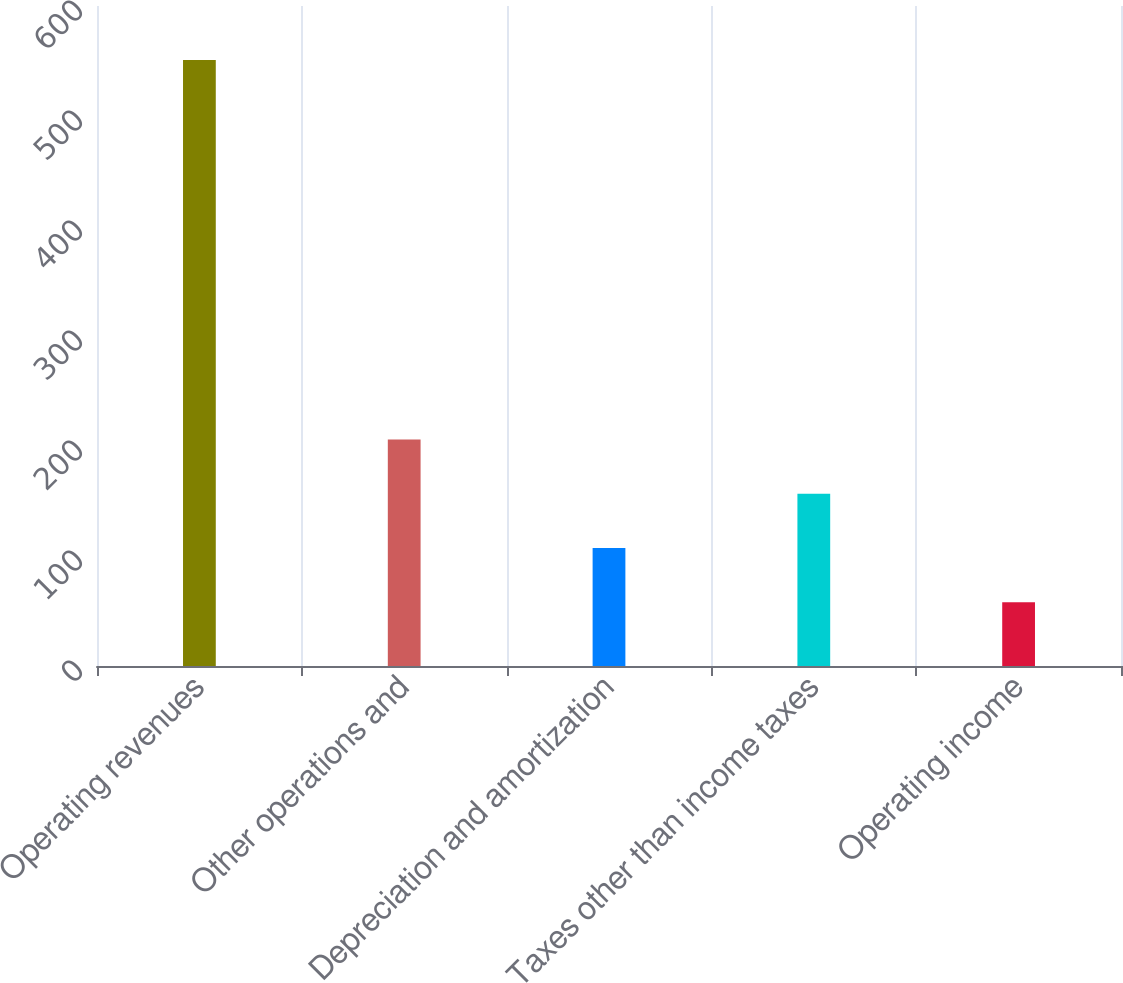<chart> <loc_0><loc_0><loc_500><loc_500><bar_chart><fcel>Operating revenues<fcel>Other operations and<fcel>Depreciation and amortization<fcel>Taxes other than income taxes<fcel>Operating income<nl><fcel>551<fcel>205.9<fcel>107.3<fcel>156.6<fcel>58<nl></chart> 